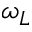<formula> <loc_0><loc_0><loc_500><loc_500>\omega _ { L }</formula> 